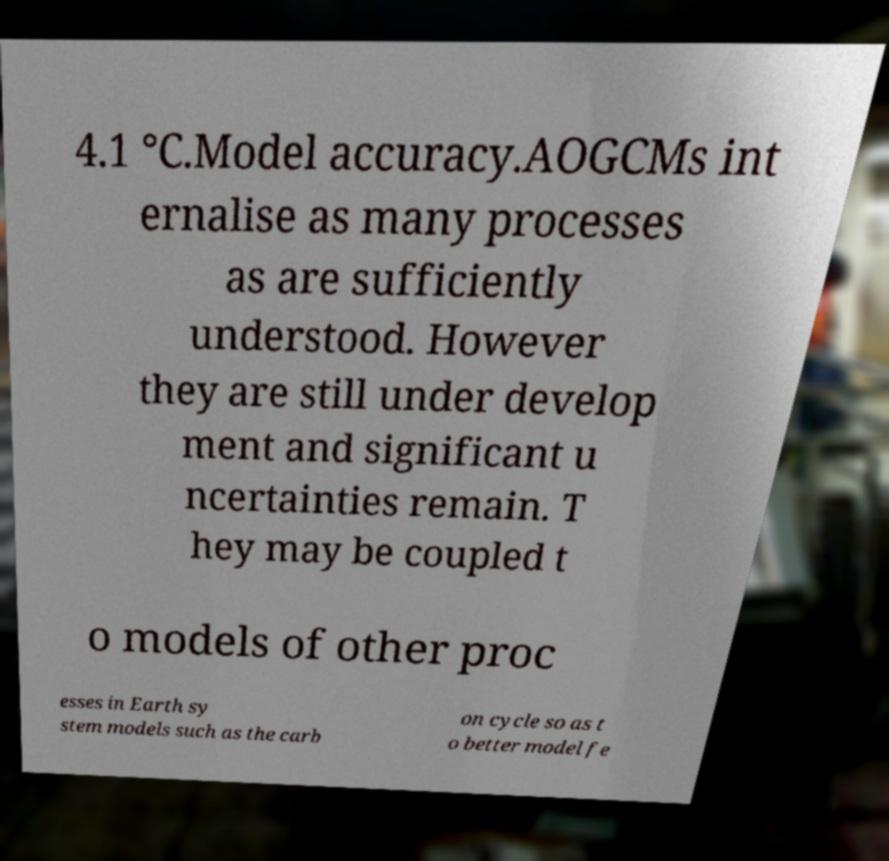Please read and relay the text visible in this image. What does it say? 4.1 °C.Model accuracy.AOGCMs int ernalise as many processes as are sufficiently understood. However they are still under develop ment and significant u ncertainties remain. T hey may be coupled t o models of other proc esses in Earth sy stem models such as the carb on cycle so as t o better model fe 